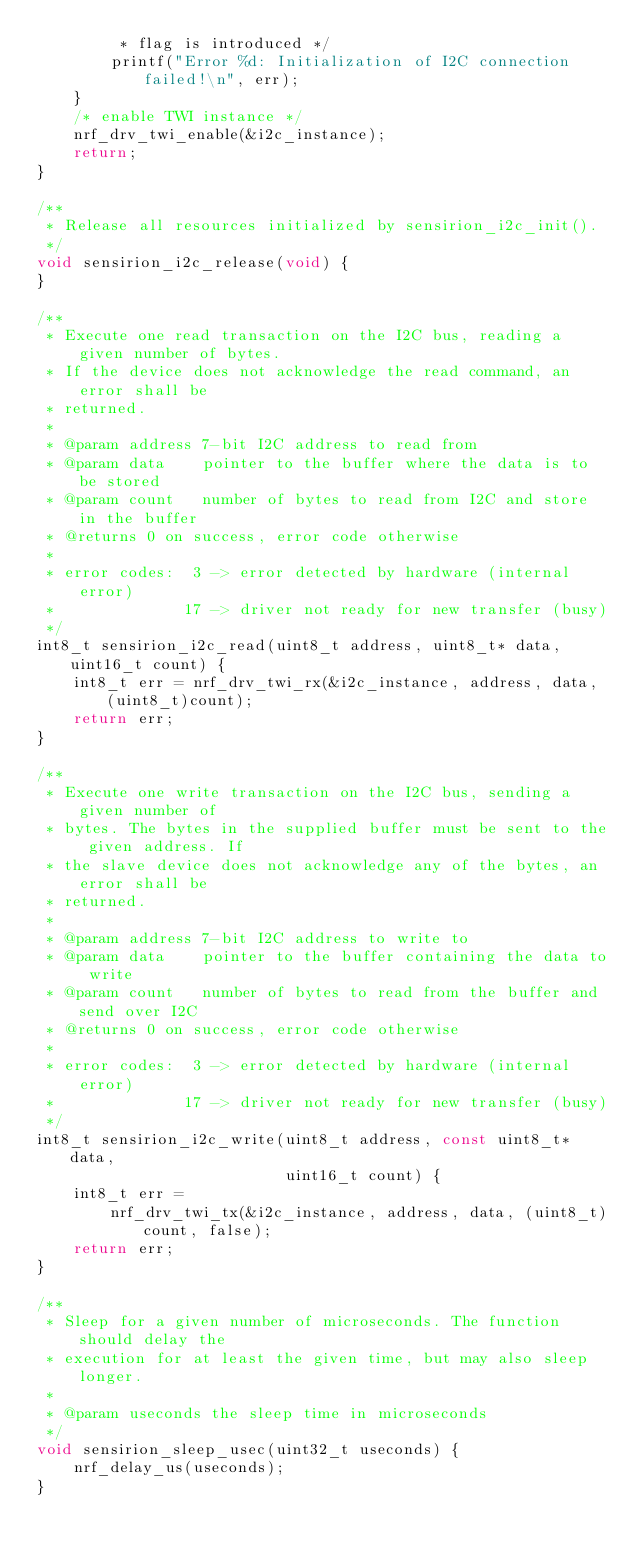<code> <loc_0><loc_0><loc_500><loc_500><_C_>         * flag is introduced */
        printf("Error %d: Initialization of I2C connection failed!\n", err);
    }
    /* enable TWI instance */
    nrf_drv_twi_enable(&i2c_instance);
    return;
}

/**
 * Release all resources initialized by sensirion_i2c_init().
 */
void sensirion_i2c_release(void) {
}

/**
 * Execute one read transaction on the I2C bus, reading a given number of bytes.
 * If the device does not acknowledge the read command, an error shall be
 * returned.
 *
 * @param address 7-bit I2C address to read from
 * @param data    pointer to the buffer where the data is to be stored
 * @param count   number of bytes to read from I2C and store in the buffer
 * @returns 0 on success, error code otherwise
 *
 * error codes:  3 -> error detected by hardware (internal error)
 *              17 -> driver not ready for new transfer (busy)
 */
int8_t sensirion_i2c_read(uint8_t address, uint8_t* data, uint16_t count) {
    int8_t err = nrf_drv_twi_rx(&i2c_instance, address, data, (uint8_t)count);
    return err;
}

/**
 * Execute one write transaction on the I2C bus, sending a given number of
 * bytes. The bytes in the supplied buffer must be sent to the given address. If
 * the slave device does not acknowledge any of the bytes, an error shall be
 * returned.
 *
 * @param address 7-bit I2C address to write to
 * @param data    pointer to the buffer containing the data to write
 * @param count   number of bytes to read from the buffer and send over I2C
 * @returns 0 on success, error code otherwise
 *
 * error codes:  3 -> error detected by hardware (internal error)
 *              17 -> driver not ready for new transfer (busy)
 */
int8_t sensirion_i2c_write(uint8_t address, const uint8_t* data,
                           uint16_t count) {
    int8_t err =
        nrf_drv_twi_tx(&i2c_instance, address, data, (uint8_t)count, false);
    return err;
}

/**
 * Sleep for a given number of microseconds. The function should delay the
 * execution for at least the given time, but may also sleep longer.
 *
 * @param useconds the sleep time in microseconds
 */
void sensirion_sleep_usec(uint32_t useconds) {
    nrf_delay_us(useconds);
}
</code> 